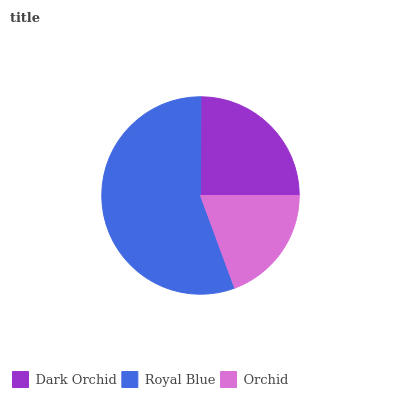Is Orchid the minimum?
Answer yes or no. Yes. Is Royal Blue the maximum?
Answer yes or no. Yes. Is Royal Blue the minimum?
Answer yes or no. No. Is Orchid the maximum?
Answer yes or no. No. Is Royal Blue greater than Orchid?
Answer yes or no. Yes. Is Orchid less than Royal Blue?
Answer yes or no. Yes. Is Orchid greater than Royal Blue?
Answer yes or no. No. Is Royal Blue less than Orchid?
Answer yes or no. No. Is Dark Orchid the high median?
Answer yes or no. Yes. Is Dark Orchid the low median?
Answer yes or no. Yes. Is Royal Blue the high median?
Answer yes or no. No. Is Royal Blue the low median?
Answer yes or no. No. 